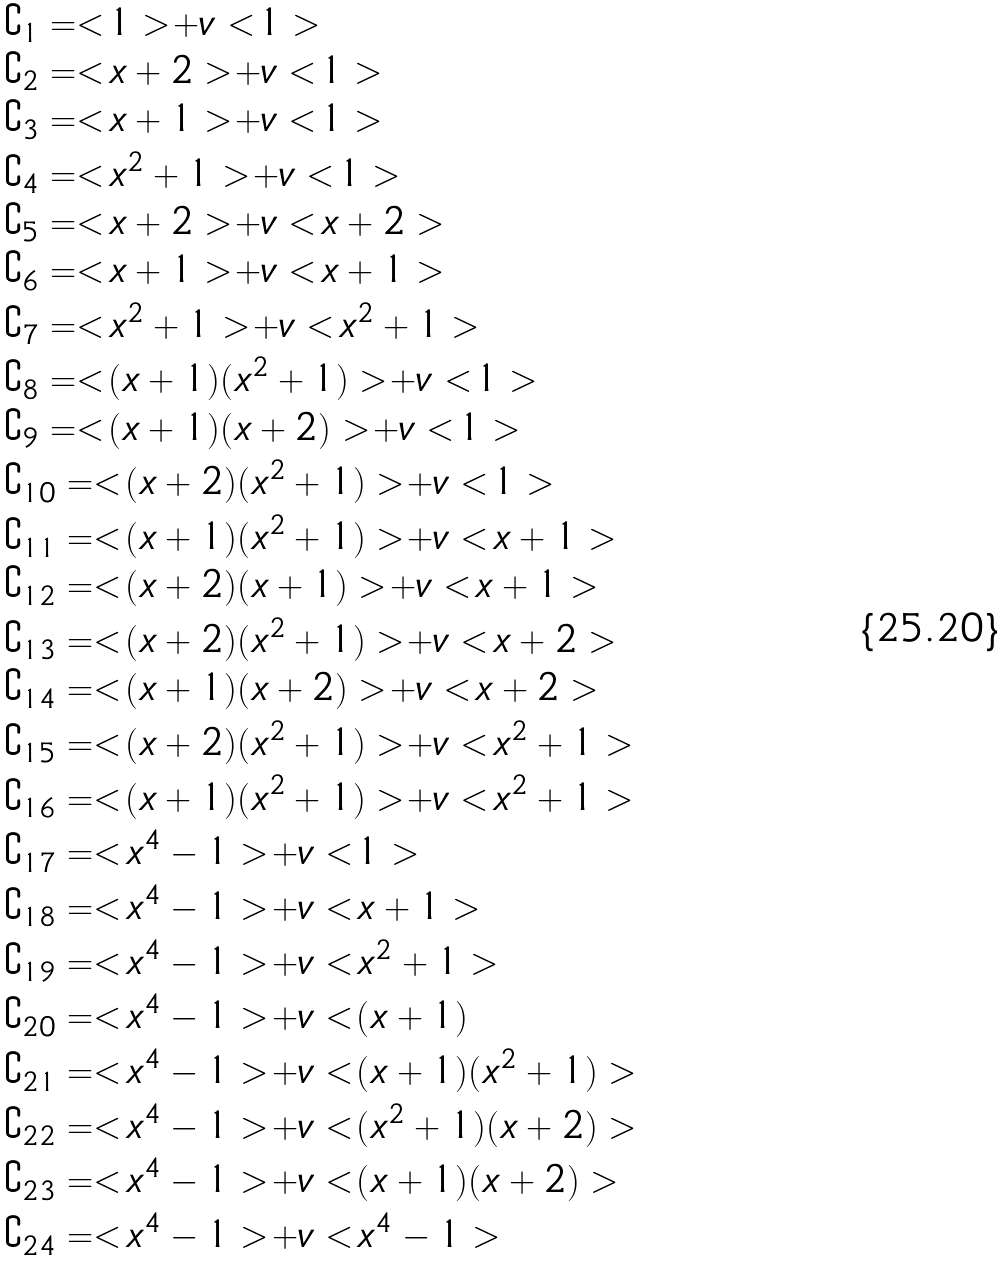<formula> <loc_0><loc_0><loc_500><loc_500>& \complement _ { 1 } = < 1 > + v < 1 > \\ & \complement _ { 2 } = < x + 2 > + v < 1 > \\ & \complement _ { 3 } = < x + 1 > + v < 1 > \\ & \complement _ { 4 } = < x ^ { 2 } + 1 > + v < 1 > \\ & \complement _ { 5 } = < x + 2 > + v < x + 2 > \\ & \complement _ { 6 } = < x + 1 > + v < x + 1 > \\ & \complement _ { 7 } = < x ^ { 2 } + 1 > + v < x ^ { 2 } + 1 > \\ & \complement _ { 8 } = < ( x + 1 ) ( x ^ { 2 } + 1 ) > + v < 1 > \\ & \complement _ { 9 } = < ( x + 1 ) ( x + 2 ) > + v < 1 > \\ & \complement _ { 1 0 } = < ( x + 2 ) ( x ^ { 2 } + 1 ) > + v < 1 > \\ & \complement _ { 1 1 } = < ( x + 1 ) ( x ^ { 2 } + 1 ) > + v < x + 1 > \\ & \complement _ { 1 2 } = < ( x + 2 ) ( x + 1 ) > + v < x + 1 > \\ & \complement _ { 1 3 } = < ( x + 2 ) ( x ^ { 2 } + 1 ) > + v < x + 2 > \\ & \complement _ { 1 4 } = < ( x + 1 ) ( x + 2 ) > + v < x + 2 > \\ & \complement _ { 1 5 } = < ( x + 2 ) ( x ^ { 2 } + 1 ) > + v < x ^ { 2 } + 1 > \\ & \complement _ { 1 6 } = < ( x + 1 ) ( x ^ { 2 } + 1 ) > + v < x ^ { 2 } + 1 > \\ & \complement _ { 1 7 } = < x ^ { 4 } - 1 > + v < 1 > \\ & \complement _ { 1 8 } = < x ^ { 4 } - 1 > + v < x + 1 > \\ & \complement _ { 1 9 } = < x ^ { 4 } - 1 > + v < x ^ { 2 } + 1 > \\ & \complement _ { 2 0 } = < x ^ { 4 } - 1 > + v < ( x + 1 ) \\ & \complement _ { 2 1 } = < x ^ { 4 } - 1 > + v < ( x + 1 ) ( x ^ { 2 } + 1 ) > \\ & \complement _ { 2 2 } = < x ^ { 4 } - 1 > + v < ( x ^ { 2 } + 1 ) ( x + 2 ) > \\ & \complement _ { 2 3 } = < x ^ { 4 } - 1 > + v < ( x + 1 ) ( x + 2 ) > \\ & \complement _ { 2 4 } = < x ^ { 4 } - 1 > + v < x ^ { 4 } - 1 ></formula> 